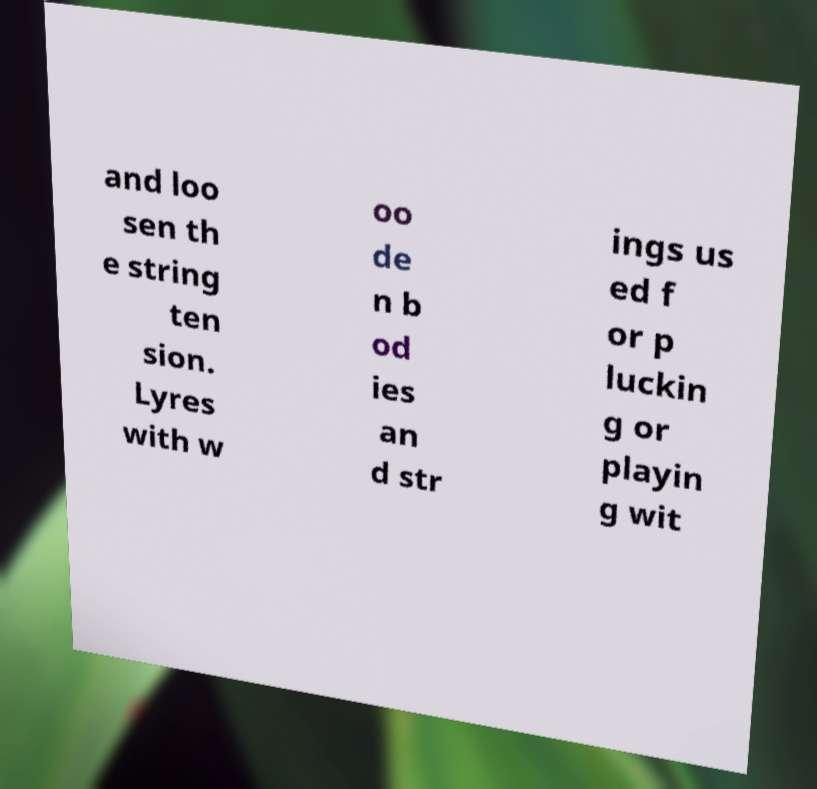I need the written content from this picture converted into text. Can you do that? and loo sen th e string ten sion. Lyres with w oo de n b od ies an d str ings us ed f or p luckin g or playin g wit 